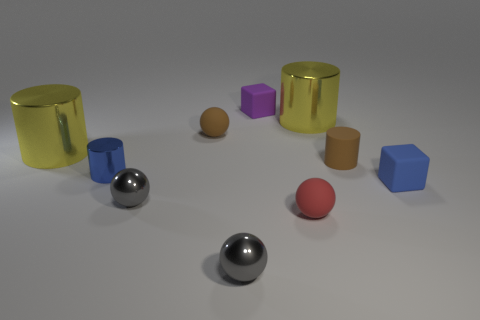There is a purple object that is the same size as the brown cylinder; what material is it?
Your answer should be very brief. Rubber. Is there another cylinder that has the same color as the tiny metallic cylinder?
Offer a very short reply. No. The matte thing that is both in front of the blue shiny thing and on the left side of the blue matte cube has what shape?
Provide a short and direct response. Sphere. How many small spheres are made of the same material as the purple thing?
Make the answer very short. 2. Are there fewer small red objects in front of the purple cube than small rubber objects in front of the brown cylinder?
Keep it short and to the point. Yes. There is a yellow object that is in front of the metallic cylinder that is behind the small rubber sphere that is behind the tiny red object; what is it made of?
Offer a terse response. Metal. There is a object that is both right of the tiny brown rubber ball and to the left of the purple rubber block; what is its size?
Give a very brief answer. Small. How many cylinders are either shiny things or tiny gray objects?
Offer a terse response. 3. The other cube that is the same size as the purple cube is what color?
Your response must be concise. Blue. Is there any other thing that is the same shape as the blue shiny thing?
Make the answer very short. Yes. 